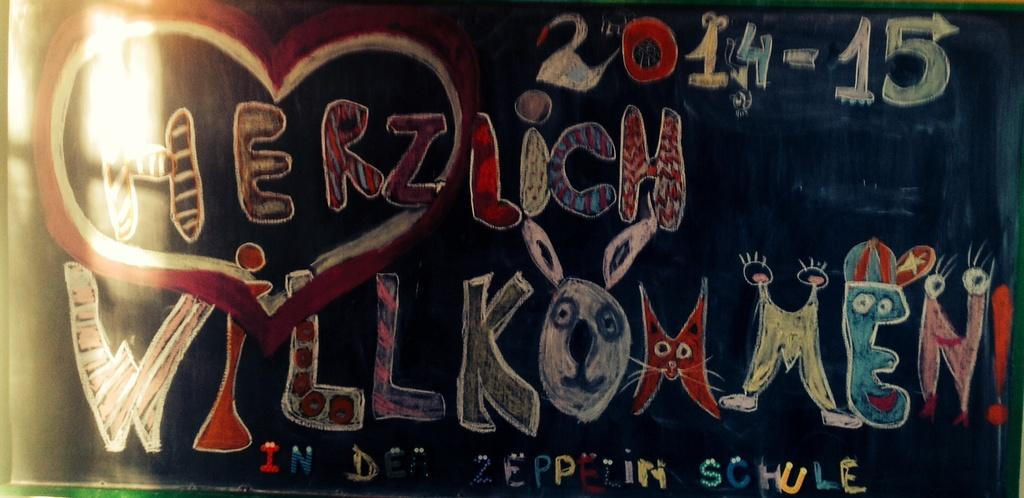What is the main object in the image? There is a blackboard in the image. What can be seen on the blackboard? Something is written on the blackboard. Can you tell me what specific information is written on the blackboard? The date is written on the blackboard. What route is the man taking in the image? There is no man or route present in the image; it only features a blackboard with writing on it. Can you describe the sail on the boat in the image? There is no boat or sail present in the image; it only features a blackboard with writing on it. 